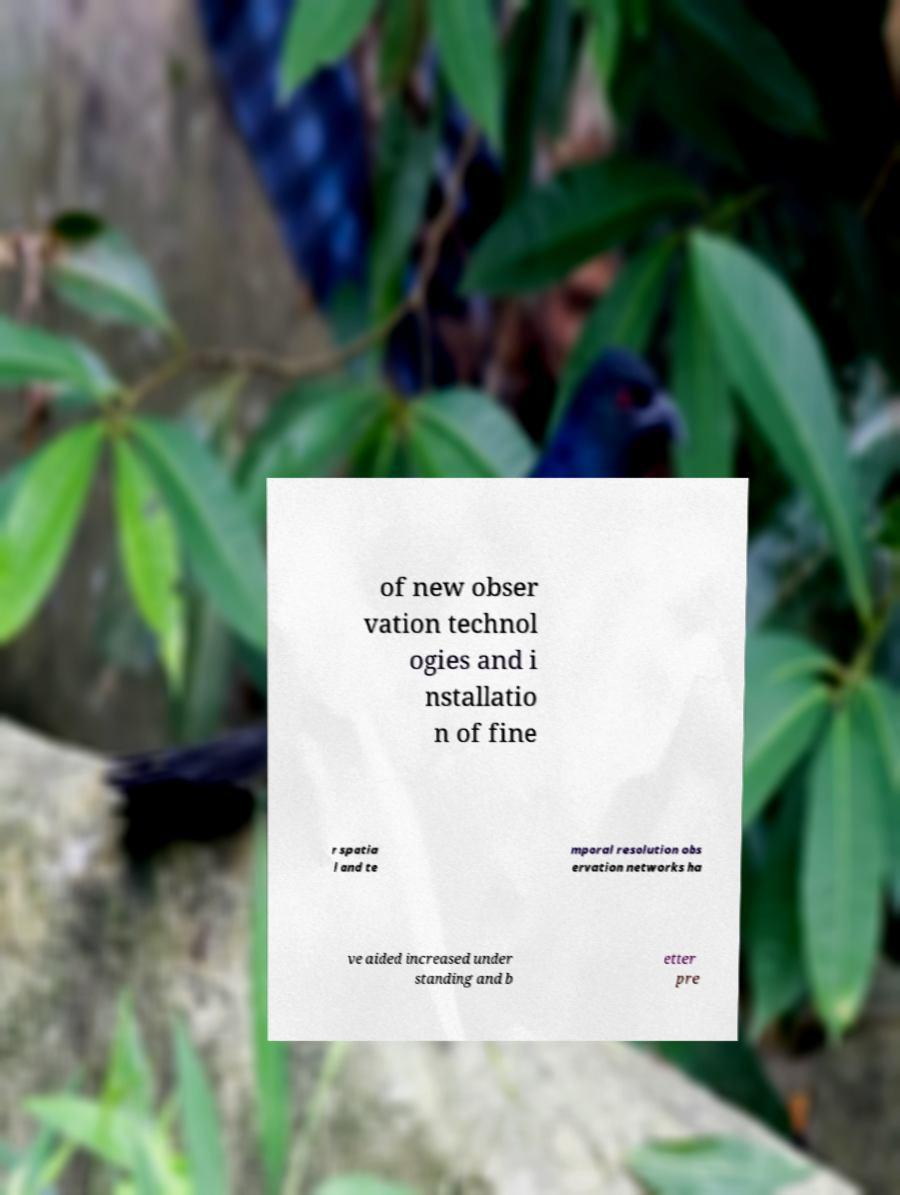Could you assist in decoding the text presented in this image and type it out clearly? of new obser vation technol ogies and i nstallatio n of fine r spatia l and te mporal resolution obs ervation networks ha ve aided increased under standing and b etter pre 